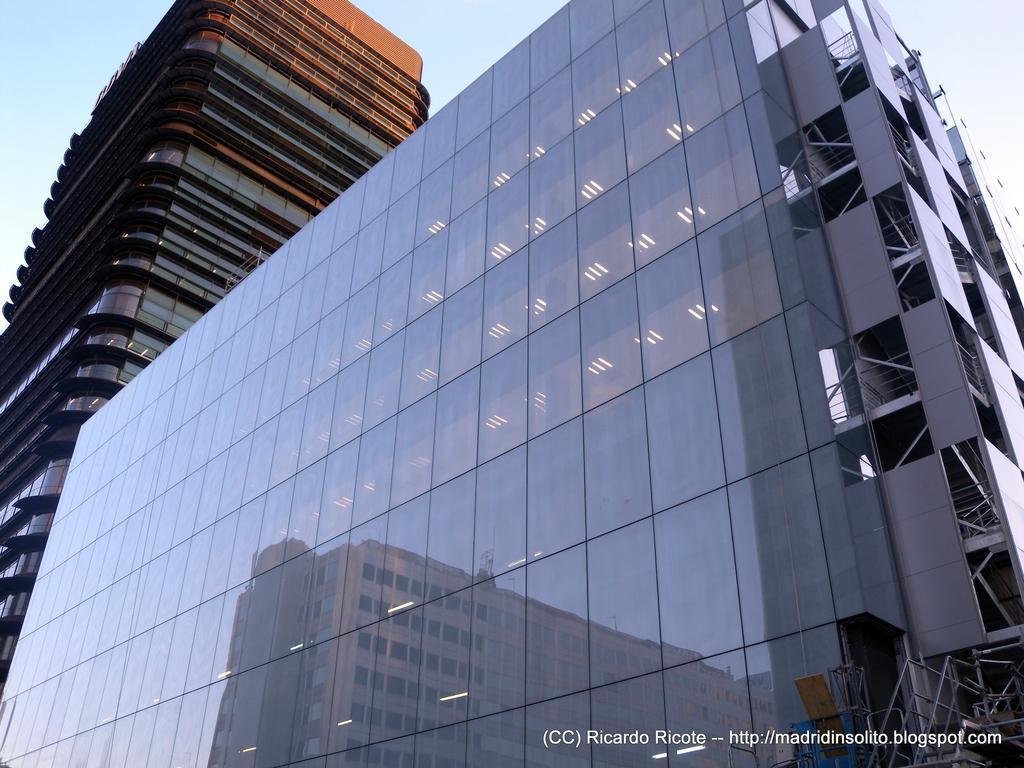How would you summarize this image in a sentence or two? In this image we can see two buildings and a reflection of a building on the other building and sky in the background. 